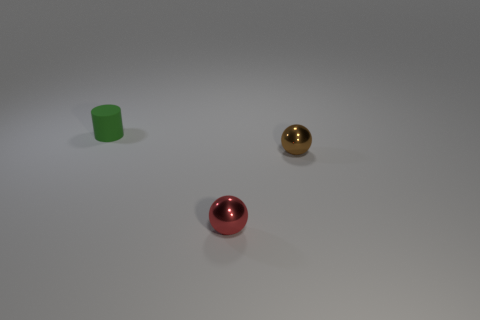Add 1 blue things. How many objects exist? 4 Subtract all cylinders. How many objects are left? 2 Add 3 yellow metal cubes. How many yellow metal cubes exist? 3 Subtract 0 purple spheres. How many objects are left? 3 Subtract all brown metal balls. Subtract all tiny brown things. How many objects are left? 1 Add 1 red metallic things. How many red metallic things are left? 2 